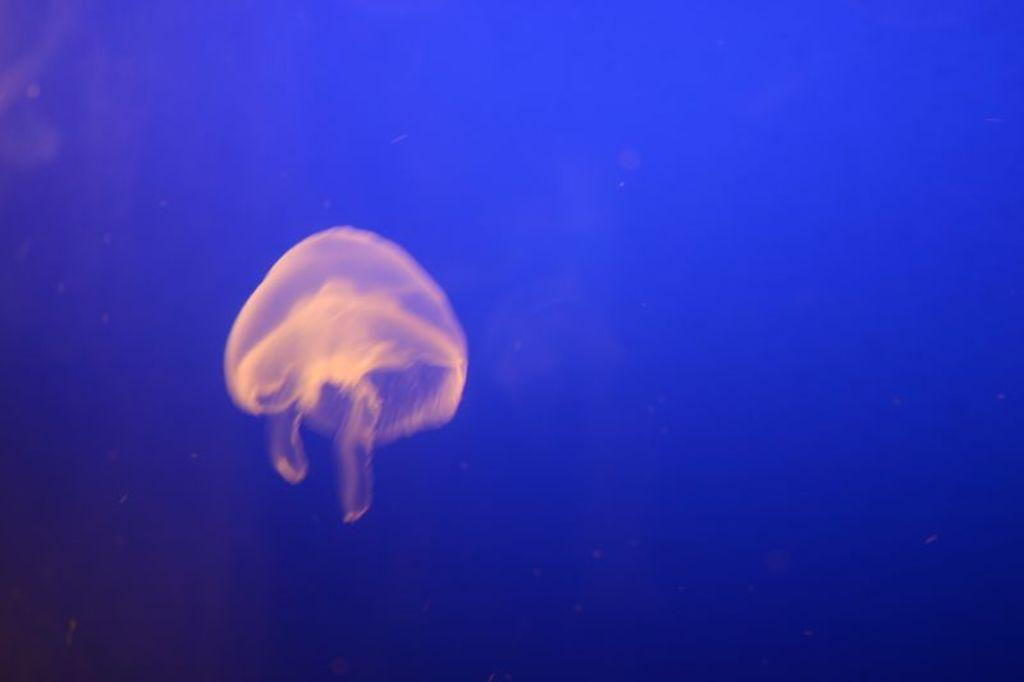What is the main subject of the image? There is a jellyfish in the center of the image. What color is the jellyfish? The jellyfish is in cream color. What can be seen in the background of the image? The background of the image is blue. What is the size of the page on which the jellyfish is printed? There is no page in the image, as it is a photograph or digital representation of the jellyfish. What is the condition of the jellyfish in the image? The jellyfish appears to be in its natural state, as it is a photograph or digital representation of the jellyfish. 